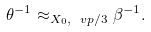<formula> <loc_0><loc_0><loc_500><loc_500>\theta ^ { - 1 } \approx _ { X _ { 0 } , \ v p / 3 } \beta ^ { - 1 } .</formula> 